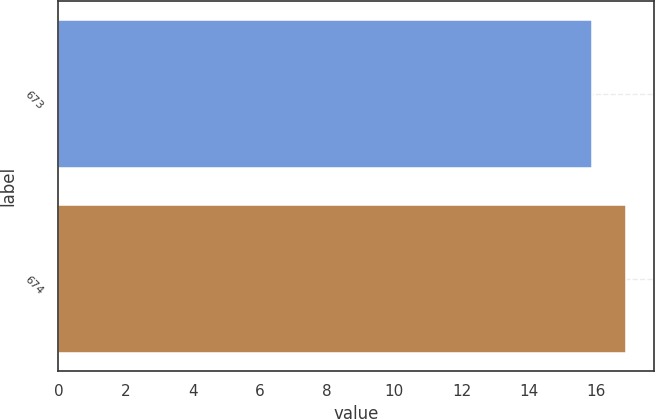<chart> <loc_0><loc_0><loc_500><loc_500><bar_chart><fcel>673<fcel>674<nl><fcel>15.9<fcel>16.9<nl></chart> 